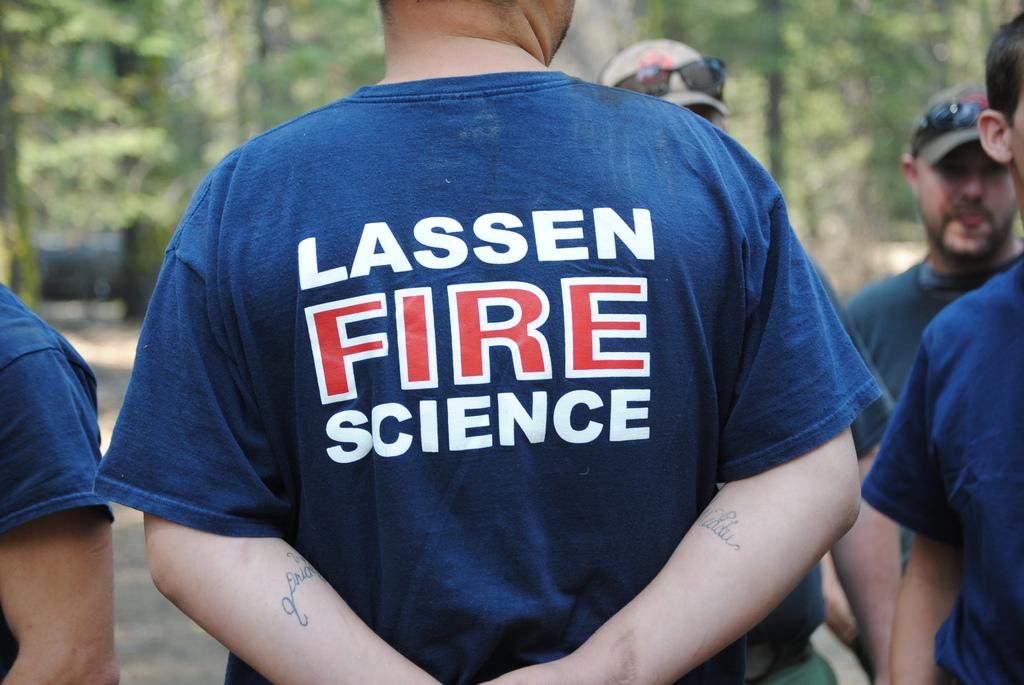Who does the person in the blue shirt represent?
Provide a short and direct response. Lassen fire science. What type of element is mentioned on the shirt?
Ensure brevity in your answer.  Fire. 